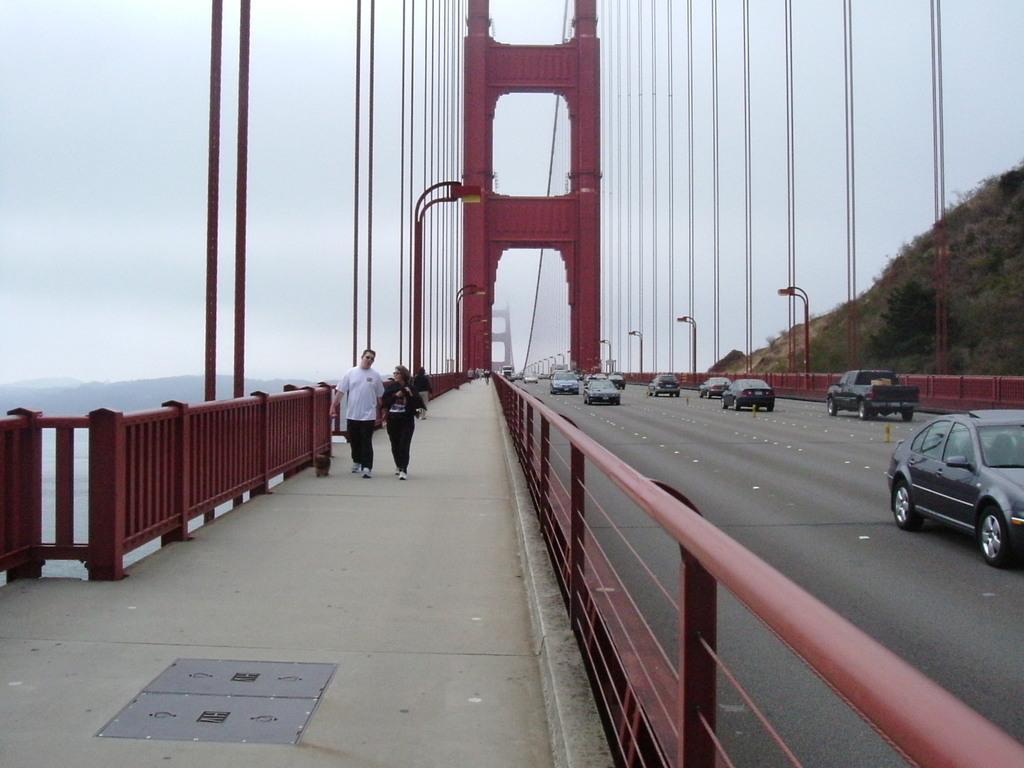In one or two sentences, can you explain what this image depicts? In the image we can see a bridge, on the bridge there are some poles and vehicles and few people are walking. Behind the bridge there is a hill. At the top of the image there is sky. 